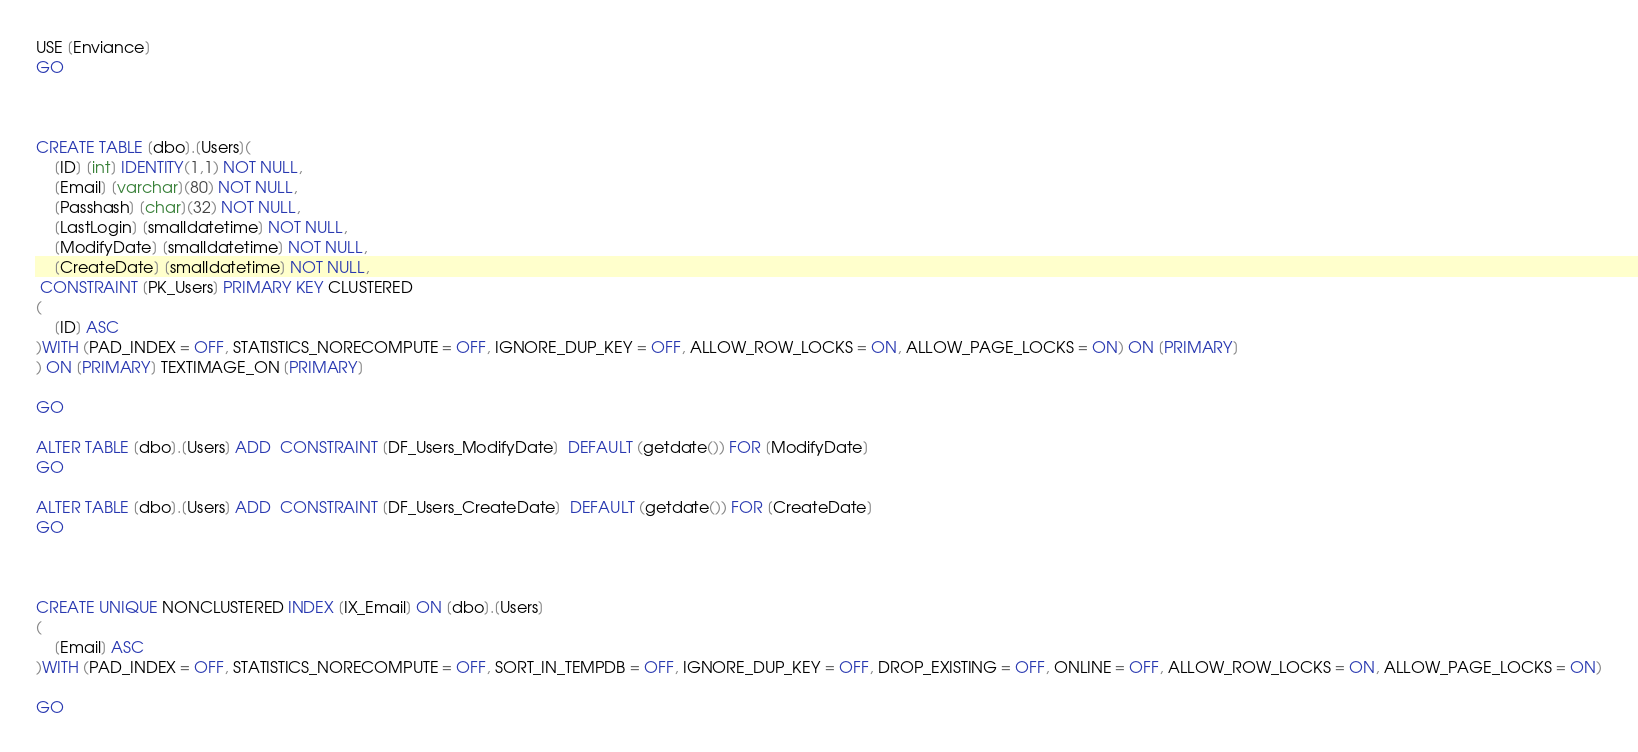Convert code to text. <code><loc_0><loc_0><loc_500><loc_500><_SQL_>

USE [Enviance]
GO



CREATE TABLE [dbo].[Users](
	[ID] [int] IDENTITY(1,1) NOT NULL,
	[Email] [varchar](80) NOT NULL,
	[Passhash] [char](32) NOT NULL,
	[LastLogin] [smalldatetime] NOT NULL,
	[ModifyDate] [smalldatetime] NOT NULL,
	[CreateDate] [smalldatetime] NOT NULL,
 CONSTRAINT [PK_Users] PRIMARY KEY CLUSTERED 
(
	[ID] ASC
)WITH (PAD_INDEX = OFF, STATISTICS_NORECOMPUTE = OFF, IGNORE_DUP_KEY = OFF, ALLOW_ROW_LOCKS = ON, ALLOW_PAGE_LOCKS = ON) ON [PRIMARY]
) ON [PRIMARY] TEXTIMAGE_ON [PRIMARY]

GO

ALTER TABLE [dbo].[Users] ADD  CONSTRAINT [DF_Users_ModifyDate]  DEFAULT (getdate()) FOR [ModifyDate]
GO

ALTER TABLE [dbo].[Users] ADD  CONSTRAINT [DF_Users_CreateDate]  DEFAULT (getdate()) FOR [CreateDate]
GO



CREATE UNIQUE NONCLUSTERED INDEX [IX_Email] ON [dbo].[Users]
(
	[Email] ASC
)WITH (PAD_INDEX = OFF, STATISTICS_NORECOMPUTE = OFF, SORT_IN_TEMPDB = OFF, IGNORE_DUP_KEY = OFF, DROP_EXISTING = OFF, ONLINE = OFF, ALLOW_ROW_LOCKS = ON, ALLOW_PAGE_LOCKS = ON)

GO

</code> 